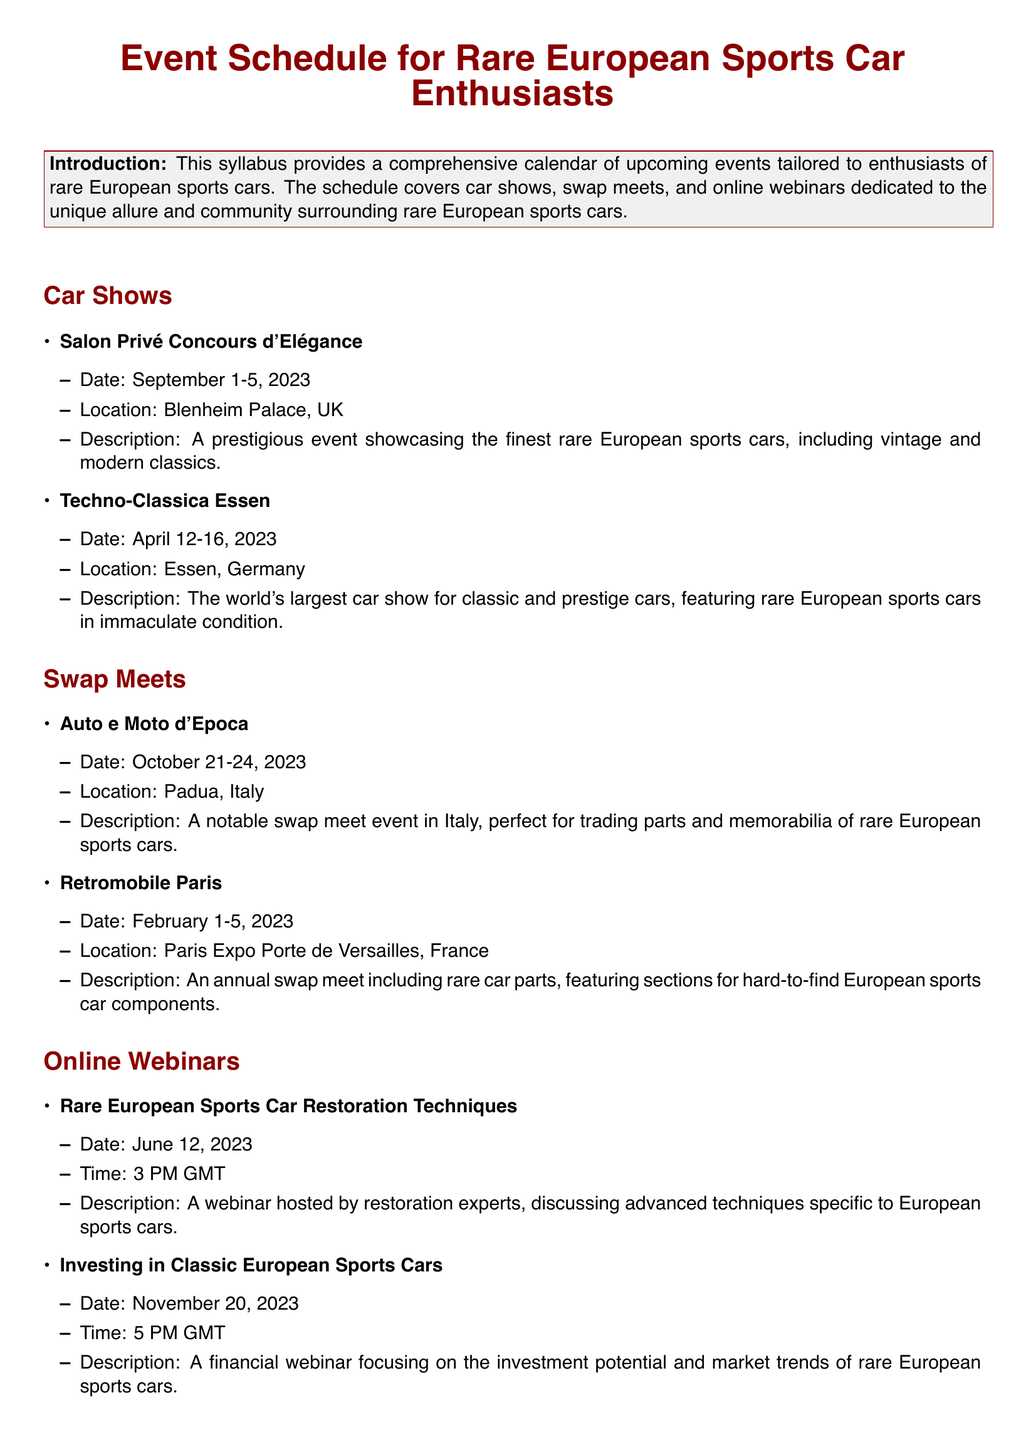What is the date for the Salon Privé Concours d'Elégance? The date for the event is specified in the document as September 1-5, 2023.
Answer: September 1-5, 2023 Where is the Techno-Classica Essen located? The location of this car show is mentioned in the document as Essen, Germany.
Answer: Essen, Germany What type of event is Auto e Moto d'Epoca? The document describes it as a notable swap meet event for trading parts and memorabilia of rare European sports cars.
Answer: Swap meet When is the next online webinar about investing in classic cars? The date given for this webinar is November 20, 2023, which is specified in the document.
Answer: November 20, 2023 What is the main focus of the webinar titled "Rare European Sports Car Restoration Techniques"? The document states this webinar will discuss advanced techniques specific to European sports cars.
Answer: Advanced techniques Which event takes place in Padua, Italy? The document specifies Auto e Moto d'Epoca as taking place in Padua, Italy.
Answer: Auto e Moto d'Epoca What location hosts the Retromobile Paris swap meet? The exact location is mentioned in the document as Paris Expo Porte de Versailles, France.
Answer: Paris Expo Porte de Versailles, France What is the focus of the online webinar scheduled for June 12, 2023? The document indicates that it will cover restoration techniques for European sports cars.
Answer: Restoration techniques How many car shows are listed in the document? Two car shows are detailed in the document.
Answer: Two 